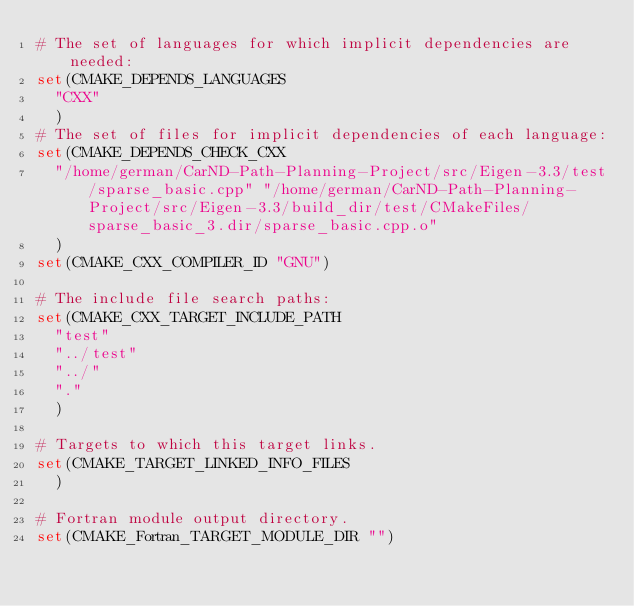<code> <loc_0><loc_0><loc_500><loc_500><_CMake_># The set of languages for which implicit dependencies are needed:
set(CMAKE_DEPENDS_LANGUAGES
  "CXX"
  )
# The set of files for implicit dependencies of each language:
set(CMAKE_DEPENDS_CHECK_CXX
  "/home/german/CarND-Path-Planning-Project/src/Eigen-3.3/test/sparse_basic.cpp" "/home/german/CarND-Path-Planning-Project/src/Eigen-3.3/build_dir/test/CMakeFiles/sparse_basic_3.dir/sparse_basic.cpp.o"
  )
set(CMAKE_CXX_COMPILER_ID "GNU")

# The include file search paths:
set(CMAKE_CXX_TARGET_INCLUDE_PATH
  "test"
  "../test"
  "../"
  "."
  )

# Targets to which this target links.
set(CMAKE_TARGET_LINKED_INFO_FILES
  )

# Fortran module output directory.
set(CMAKE_Fortran_TARGET_MODULE_DIR "")
</code> 